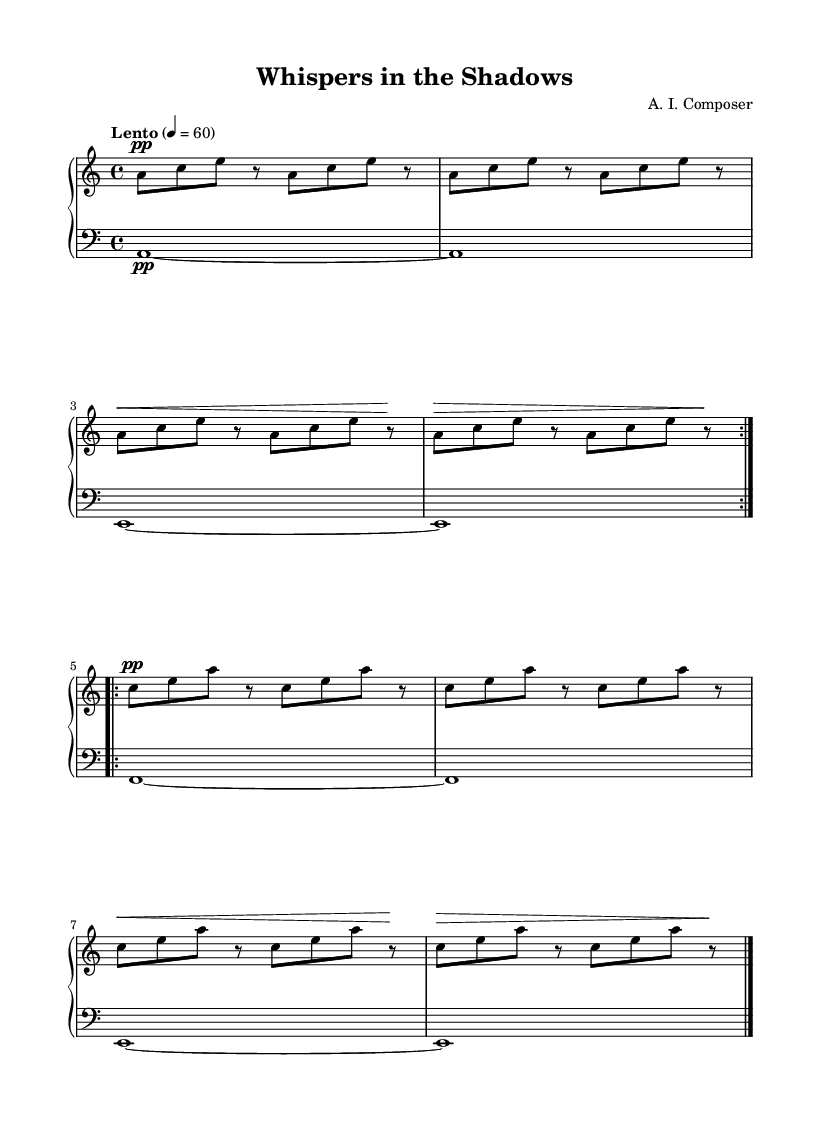What is the key signature of this music? The key signature indicated at the beginning of the staff shows one flat (B flat), which corresponds to A minor.
Answer: A minor What is the time signature of this music? The time signature is seen in the beginning of the staff as a four over four, indicating a regular meter with four beats per measure.
Answer: 4/4 What is the tempo marking of the piece? The tempo marking in the score states "Lento," which indicates a slow tempo. The number "4 = 60" means there are 60 beats per minute.
Answer: Lento How many measures are repeated in the right hand? The right hand explicitly shows the repeat signs with "volta 2," indicating that the section is played twice, therefore totaling two measures.
Answer: 2 What dynamic marking is indicated at the beginning of the right hand's first section? The dynamic marking at the beginning of the right hand's first section indicates "pp," which denotes a very soft dynamic level in music.
Answer: pp What is the lowest note played in the left hand? The lowest note indicated in the left hand is "A," which is shown in the bass clef at the beginning of the staff.
Answer: A How does the dynamic change in the right hand during the repeated section? The right hand shows a crescendo from "pp" to "f," meaning it starts very soft and gradually becomes loud before returning to soft again, as indicated by the "!" marking.
Answer: pp to f 